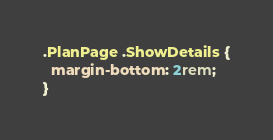<code> <loc_0><loc_0><loc_500><loc_500><_CSS_>.PlanPage .ShowDetails {
  margin-bottom: 2rem;
}
</code> 